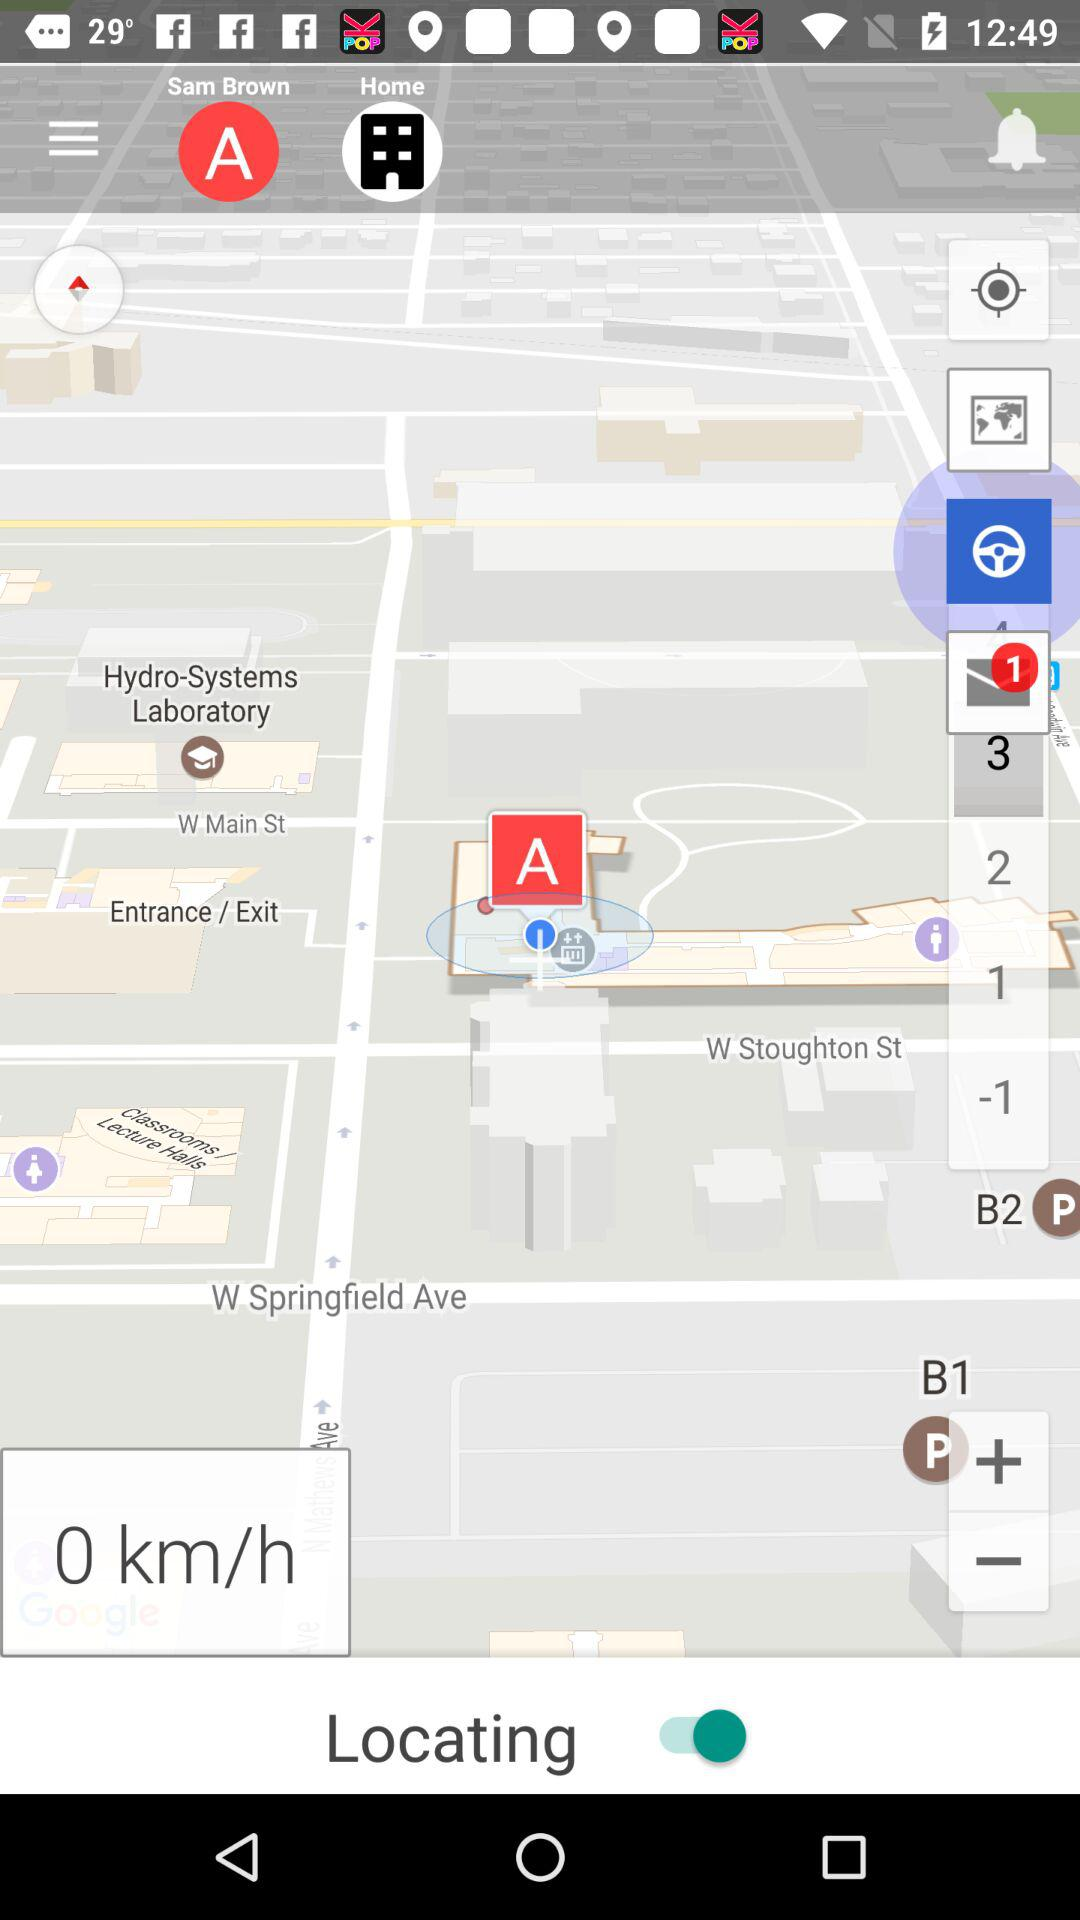What is the status of the "Locating"? The status is "on". 